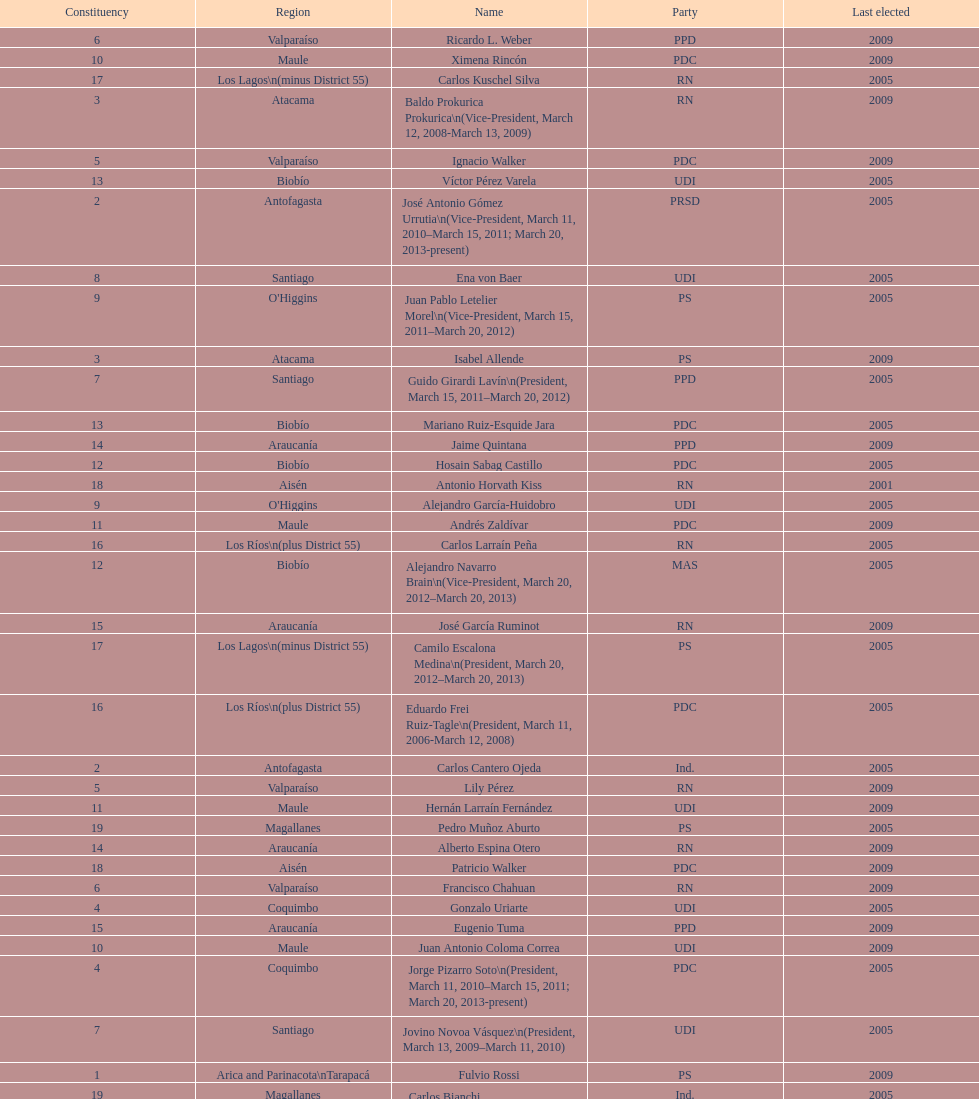What is the last region listed on the table? Magallanes. 